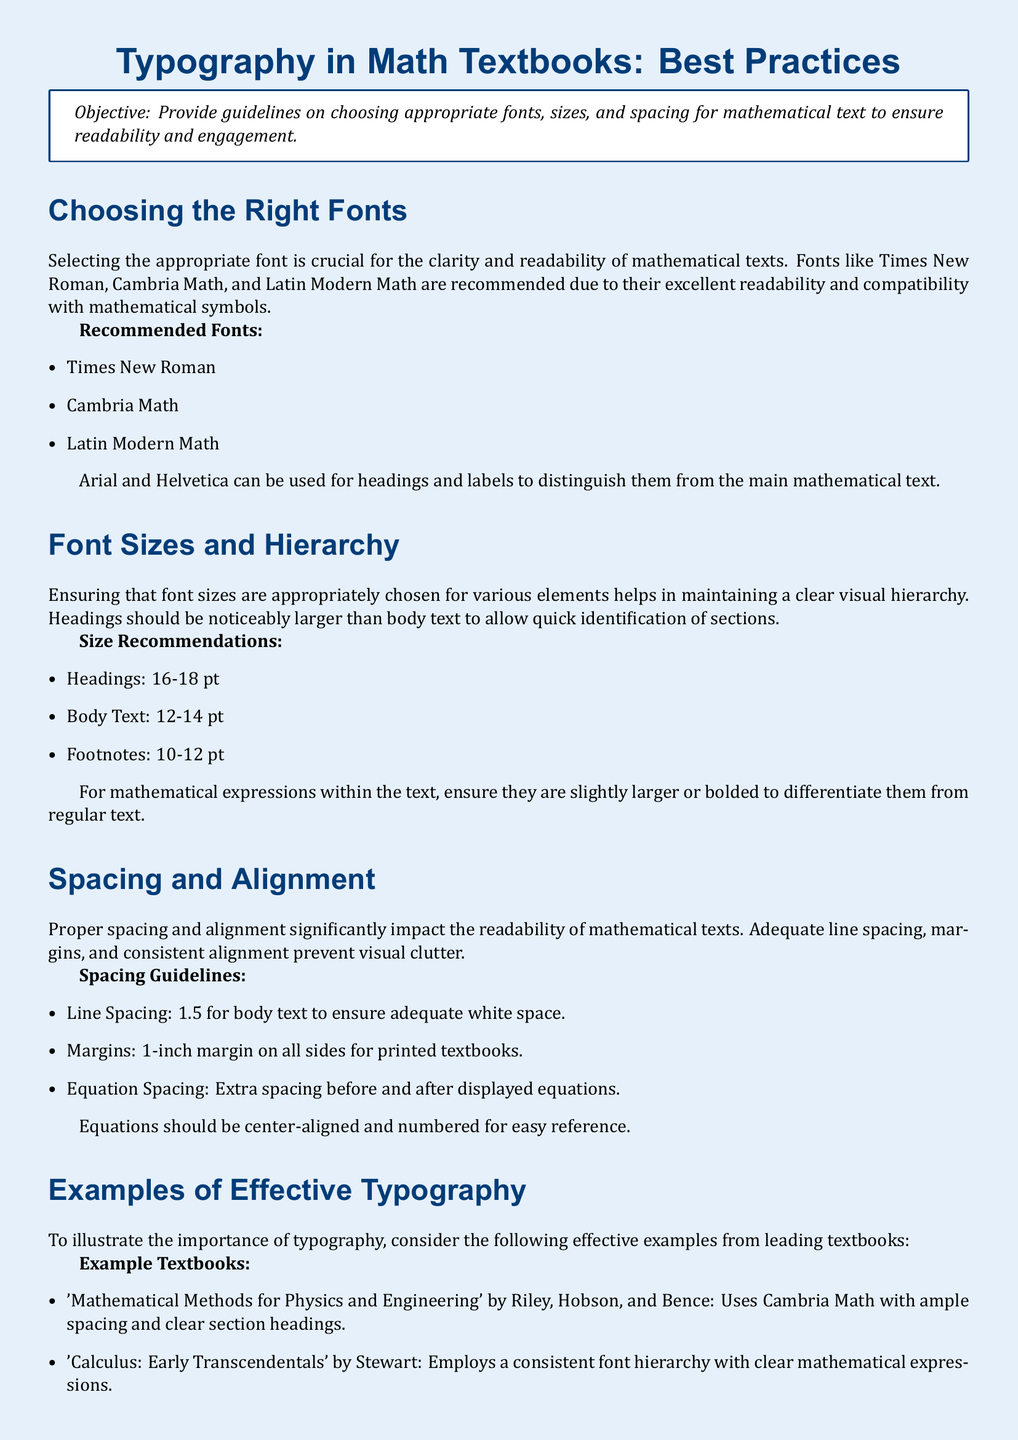What are the recommended fonts for math texts? The document lists specific font recommendations for mathematical texts to enhance readability, which include Times New Roman, Cambria Math, and Latin Modern Math.
Answer: Times New Roman, Cambria Math, Latin Modern Math What size is recommended for body text? The document provides size recommendations for different text elements, stating that body text should be between 12 and 14 point.
Answer: 12-14 pt What is the suggested line spacing for body text? It specifies that the line spacing for body text should be set to 1.5 to provide adequate white space for readability.
Answer: 1.5 Which headings size should be used? The typographical guidelines indicate that headings should be noticeably larger, recommending a size of 16 to 18 point for headings.
Answer: 16-18 pt What is a common mistake to avoid in typography? The document outlines several mistakes to avoid, one of which is using too many font types throughout the text.
Answer: Using too many fonts types What is the purpose of spacing before and after displayed equations? Adequate spacing is emphasized in the document to enhance clarity and prevent visual clutter around equations.
Answer: Clarity What type of font is suggested for headings? The document advises using Arial and Helvetica for headings to distinguish them from main mathematical text.
Answer: Arial, Helvetica How should equations be aligned in math textbooks? The guidelines specify that equations should be center-aligned for easy reference.
Answer: Center-aligned What color is used for the page background? The document specifies a light blue color is used for the page background to create a pleasant visual appeal.
Answer: Light blue 